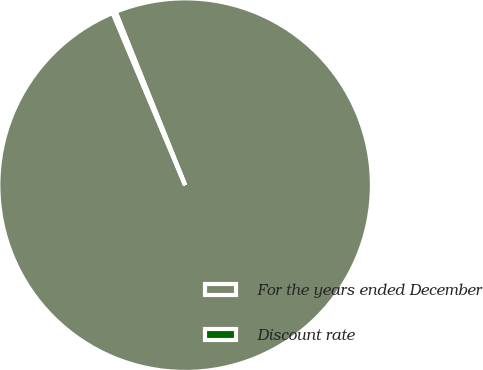Convert chart to OTSL. <chart><loc_0><loc_0><loc_500><loc_500><pie_chart><fcel>For the years ended December<fcel>Discount rate<nl><fcel>99.73%<fcel>0.27%<nl></chart> 